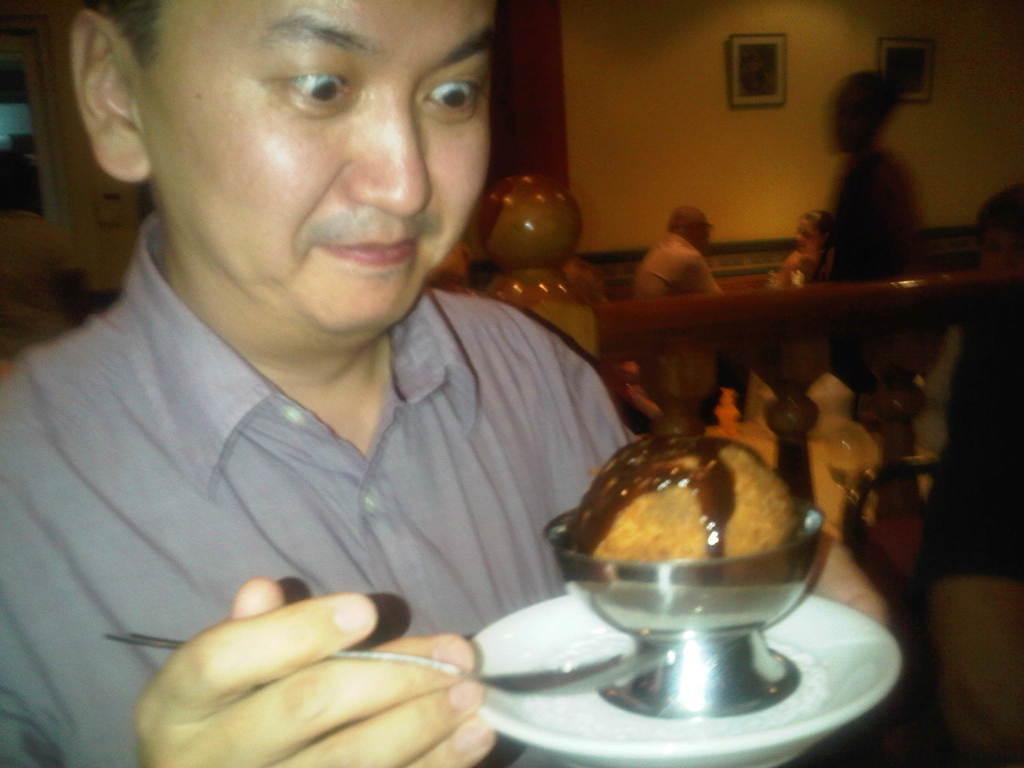Can you describe this image briefly? In this image, there is a man holding a white color plate and there is a ice cream, the man is holding a spoon and he is looking at the ice cream, in the background there are some people sitting and there is a wall. 